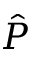Convert formula to latex. <formula><loc_0><loc_0><loc_500><loc_500>\hat { P }</formula> 